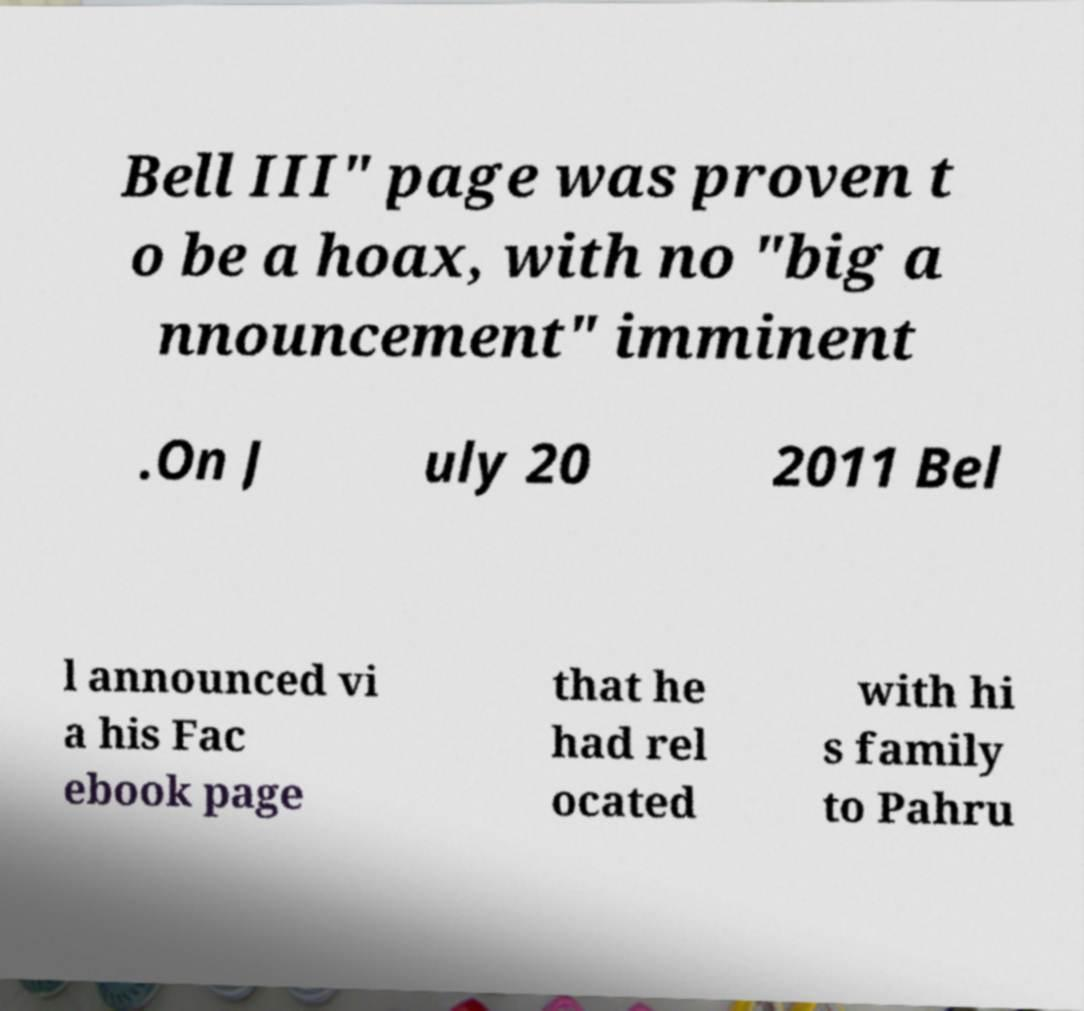Can you read and provide the text displayed in the image?This photo seems to have some interesting text. Can you extract and type it out for me? Bell III" page was proven t o be a hoax, with no "big a nnouncement" imminent .On J uly 20 2011 Bel l announced vi a his Fac ebook page that he had rel ocated with hi s family to Pahru 